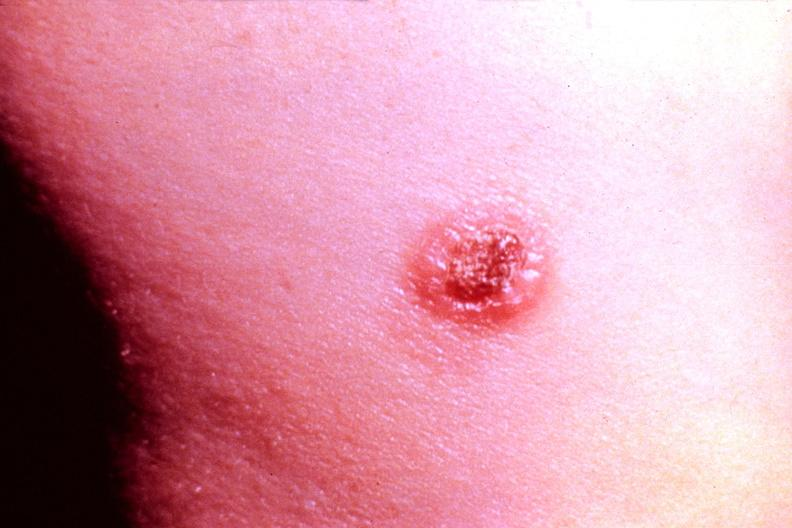what does this image show?
Answer the question using a single word or phrase. Cryptococcal dematitis 